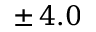Convert formula to latex. <formula><loc_0><loc_0><loc_500><loc_500>\pm \, 4 . 0</formula> 